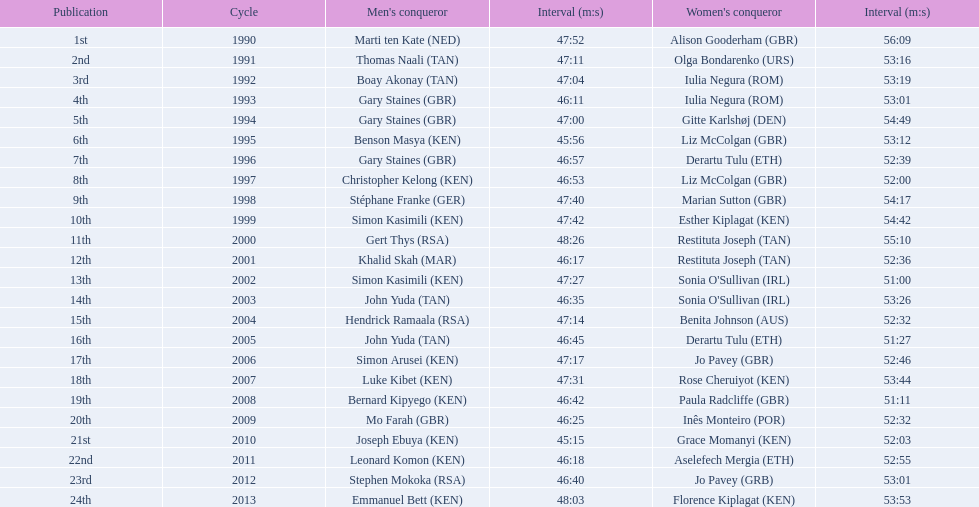Which of the runner in the great south run were women? Alison Gooderham (GBR), Olga Bondarenko (URS), Iulia Negura (ROM), Iulia Negura (ROM), Gitte Karlshøj (DEN), Liz McColgan (GBR), Derartu Tulu (ETH), Liz McColgan (GBR), Marian Sutton (GBR), Esther Kiplagat (KEN), Restituta Joseph (TAN), Restituta Joseph (TAN), Sonia O'Sullivan (IRL), Sonia O'Sullivan (IRL), Benita Johnson (AUS), Derartu Tulu (ETH), Jo Pavey (GBR), Rose Cheruiyot (KEN), Paula Radcliffe (GBR), Inês Monteiro (POR), Grace Momanyi (KEN), Aselefech Mergia (ETH), Jo Pavey (GRB), Florence Kiplagat (KEN). Of those women, which ones had a time of at least 53 minutes? Alison Gooderham (GBR), Olga Bondarenko (URS), Iulia Negura (ROM), Iulia Negura (ROM), Gitte Karlshøj (DEN), Liz McColgan (GBR), Marian Sutton (GBR), Esther Kiplagat (KEN), Restituta Joseph (TAN), Sonia O'Sullivan (IRL), Rose Cheruiyot (KEN), Jo Pavey (GRB), Florence Kiplagat (KEN). Between those women, which ones did not go over 53 minutes? Olga Bondarenko (URS), Iulia Negura (ROM), Iulia Negura (ROM), Liz McColgan (GBR), Sonia O'Sullivan (IRL), Rose Cheruiyot (KEN), Jo Pavey (GRB), Florence Kiplagat (KEN). Of those 8, what were the three slowest times? Sonia O'Sullivan (IRL), Rose Cheruiyot (KEN), Florence Kiplagat (KEN). Between only those 3 women, which runner had the fastest time? Sonia O'Sullivan (IRL). What was this women's time? 53:26. 